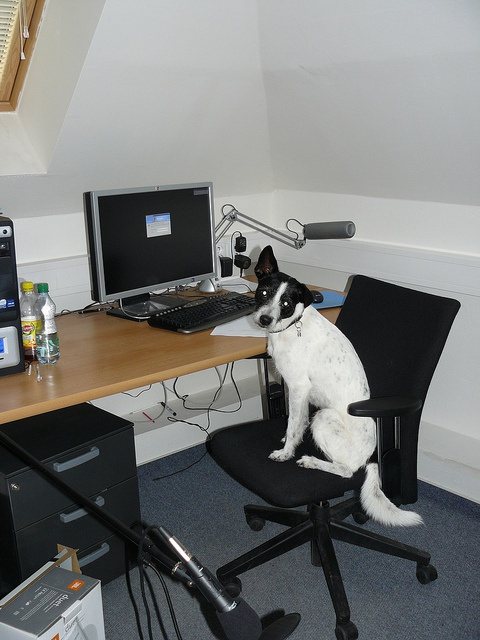Describe the objects in this image and their specific colors. I can see chair in darkgray, black, and purple tones, dog in darkgray, lightgray, black, and gray tones, tv in darkgray, black, and gray tones, keyboard in darkgray, black, and gray tones, and bottle in darkgray, gray, and lightgray tones in this image. 